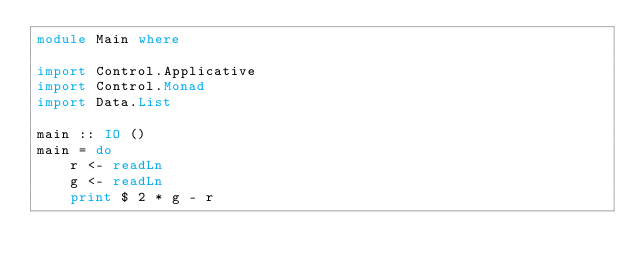<code> <loc_0><loc_0><loc_500><loc_500><_Haskell_>module Main where

import Control.Applicative
import Control.Monad
import Data.List

main :: IO ()
main = do
    r <- readLn
    g <- readLn
    print $ 2 * g - r</code> 